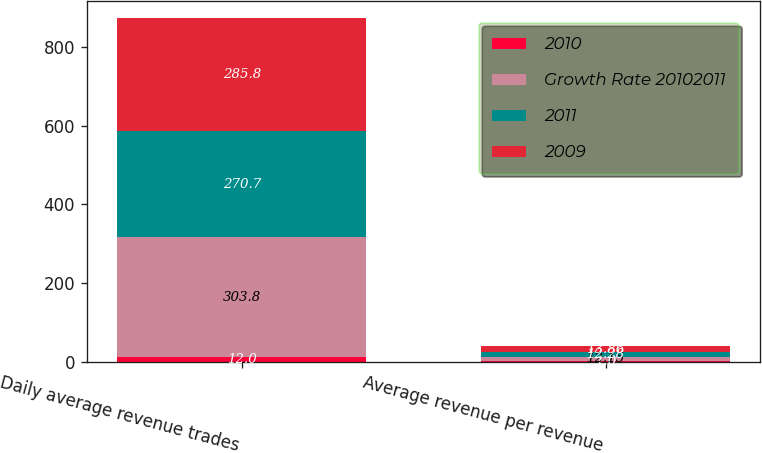<chart> <loc_0><loc_0><loc_500><loc_500><stacked_bar_chart><ecel><fcel>Daily average revenue trades<fcel>Average revenue per revenue<nl><fcel>2010<fcel>12<fcel>1<nl><fcel>Growth Rate 20102011<fcel>303.8<fcel>12.15<nl><fcel>2011<fcel>270.7<fcel>12.28<nl><fcel>2009<fcel>285.8<fcel>13.86<nl></chart> 